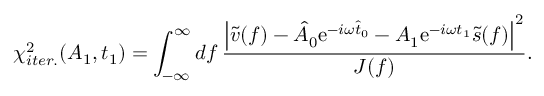<formula> <loc_0><loc_0><loc_500><loc_500>\chi _ { i t e r . } ^ { 2 } ( A _ { 1 } , t _ { 1 } ) = \int _ { - \infty } ^ { \infty } d f \frac { \left | \tilde { v } ( f ) - \hat { A } _ { 0 } e ^ { - i \omega \hat { t } _ { 0 } } - A _ { 1 } e ^ { - i \omega t _ { 1 } } \tilde { s } ( f ) \right | ^ { 2 } } { J ( f ) } .</formula> 